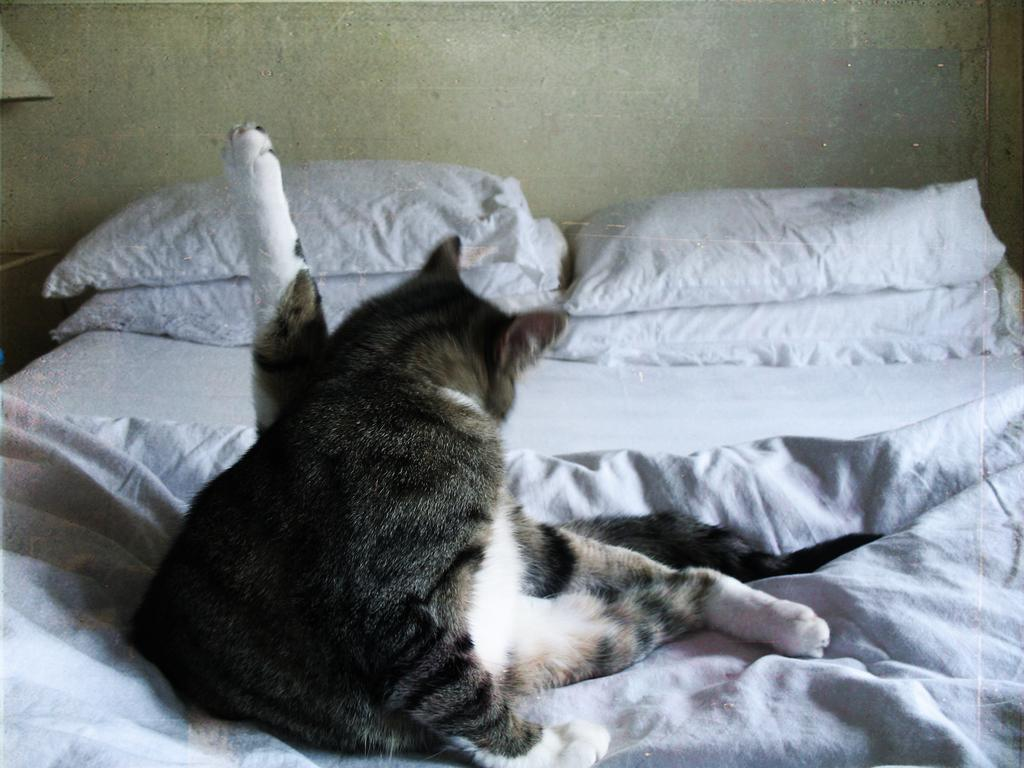What animal is present in the image? There is a cat in the image. Where is the cat located? The cat is sitting on a bed. What else can be seen on the bed? There are pillows on the bed. What type of boundary can be seen in the image? There is no boundary present in the image; it features a cat sitting on a bed with pillows. Is there a scarecrow visible in the image? No, there is no scarecrow present in the image. 